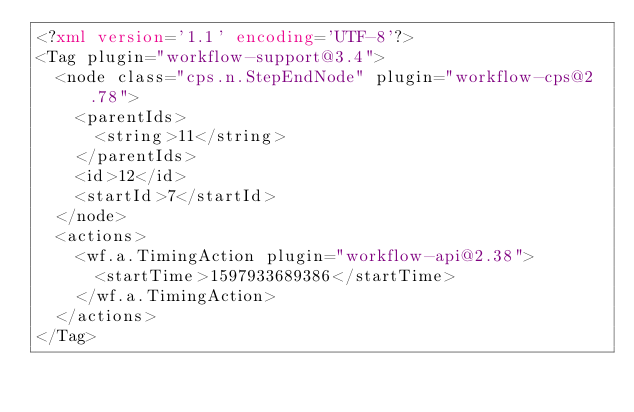<code> <loc_0><loc_0><loc_500><loc_500><_XML_><?xml version='1.1' encoding='UTF-8'?>
<Tag plugin="workflow-support@3.4">
  <node class="cps.n.StepEndNode" plugin="workflow-cps@2.78">
    <parentIds>
      <string>11</string>
    </parentIds>
    <id>12</id>
    <startId>7</startId>
  </node>
  <actions>
    <wf.a.TimingAction plugin="workflow-api@2.38">
      <startTime>1597933689386</startTime>
    </wf.a.TimingAction>
  </actions>
</Tag></code> 